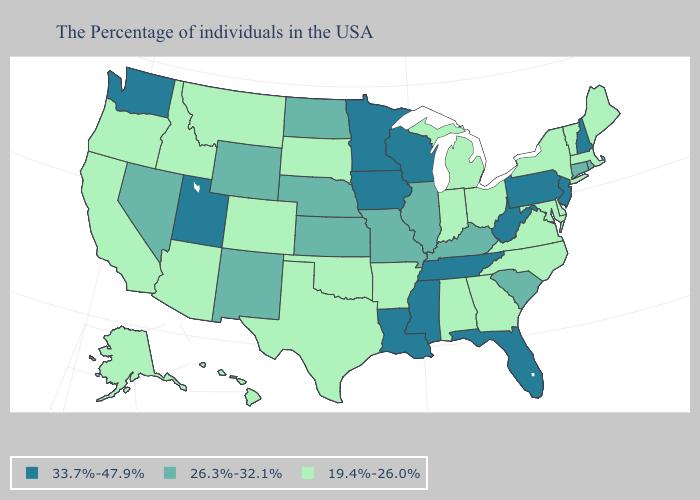Does Arkansas have a lower value than Utah?
Be succinct. Yes. Does the map have missing data?
Answer briefly. No. Does North Carolina have the lowest value in the South?
Answer briefly. Yes. Name the states that have a value in the range 33.7%-47.9%?
Write a very short answer. New Hampshire, New Jersey, Pennsylvania, West Virginia, Florida, Tennessee, Wisconsin, Mississippi, Louisiana, Minnesota, Iowa, Utah, Washington. Does Wisconsin have the lowest value in the MidWest?
Short answer required. No. Is the legend a continuous bar?
Quick response, please. No. Name the states that have a value in the range 26.3%-32.1%?
Give a very brief answer. Rhode Island, Connecticut, South Carolina, Kentucky, Illinois, Missouri, Kansas, Nebraska, North Dakota, Wyoming, New Mexico, Nevada. What is the value of Texas?
Short answer required. 19.4%-26.0%. What is the highest value in the West ?
Short answer required. 33.7%-47.9%. Which states have the lowest value in the USA?
Answer briefly. Maine, Massachusetts, Vermont, New York, Delaware, Maryland, Virginia, North Carolina, Ohio, Georgia, Michigan, Indiana, Alabama, Arkansas, Oklahoma, Texas, South Dakota, Colorado, Montana, Arizona, Idaho, California, Oregon, Alaska, Hawaii. How many symbols are there in the legend?
Quick response, please. 3. Which states hav the highest value in the South?
Quick response, please. West Virginia, Florida, Tennessee, Mississippi, Louisiana. Does the map have missing data?
Give a very brief answer. No. Name the states that have a value in the range 26.3%-32.1%?
Concise answer only. Rhode Island, Connecticut, South Carolina, Kentucky, Illinois, Missouri, Kansas, Nebraska, North Dakota, Wyoming, New Mexico, Nevada. What is the value of California?
Be succinct. 19.4%-26.0%. 